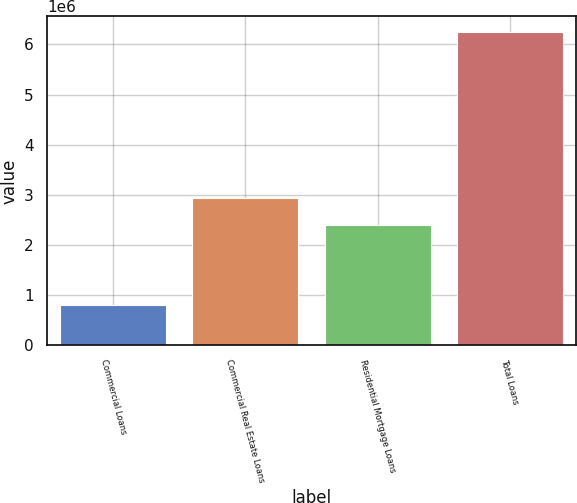Convert chart. <chart><loc_0><loc_0><loc_500><loc_500><bar_chart><fcel>Commercial Loans<fcel>Commercial Real Estate Loans<fcel>Residential Mortgage Loans<fcel>Total Loans<nl><fcel>805017<fcel>2.94261e+06<fcel>2.39847e+06<fcel>6.24634e+06<nl></chart> 